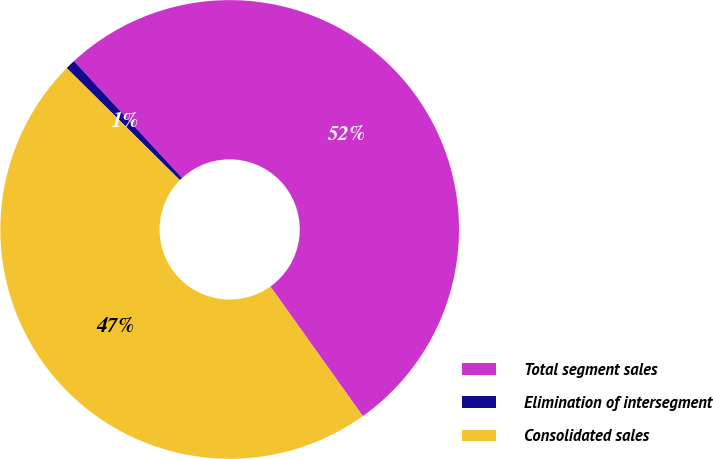Convert chart to OTSL. <chart><loc_0><loc_0><loc_500><loc_500><pie_chart><fcel>Total segment sales<fcel>Elimination of intersegment<fcel>Consolidated sales<nl><fcel>52.02%<fcel>0.7%<fcel>47.28%<nl></chart> 